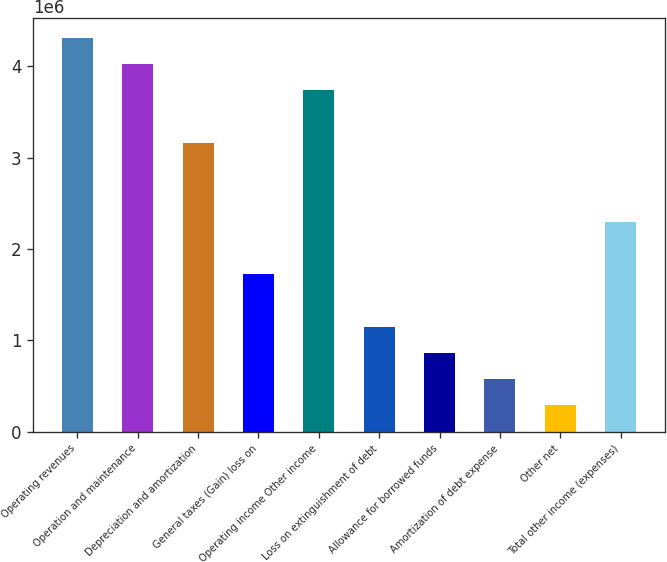Convert chart to OTSL. <chart><loc_0><loc_0><loc_500><loc_500><bar_chart><fcel>Operating revenues<fcel>Operation and maintenance<fcel>Depreciation and amortization<fcel>General taxes (Gain) loss on<fcel>Operating income Other income<fcel>Loss on extinguishment of debt<fcel>Allowance for borrowed funds<fcel>Amortization of debt expense<fcel>Other net<fcel>Total other income (expenses)<nl><fcel>4.31533e+06<fcel>4.02764e+06<fcel>3.16458e+06<fcel>1.72613e+06<fcel>3.73996e+06<fcel>1.15076e+06<fcel>863067<fcel>575378<fcel>287689<fcel>2.30151e+06<nl></chart> 